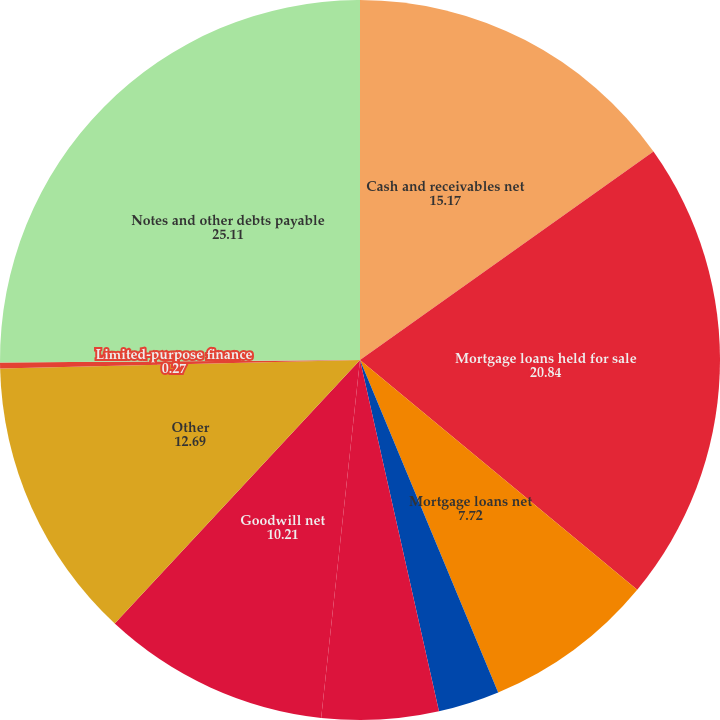Convert chart. <chart><loc_0><loc_0><loc_500><loc_500><pie_chart><fcel>Cash and receivables net<fcel>Mortgage loans held for sale<fcel>Mortgage loans net<fcel>Title plants<fcel>Investment securities<fcel>Goodwill net<fcel>Other<fcel>Limited-purpose finance<fcel>Notes and other debts payable<nl><fcel>15.17%<fcel>20.84%<fcel>7.72%<fcel>2.75%<fcel>5.24%<fcel>10.21%<fcel>12.69%<fcel>0.27%<fcel>25.11%<nl></chart> 